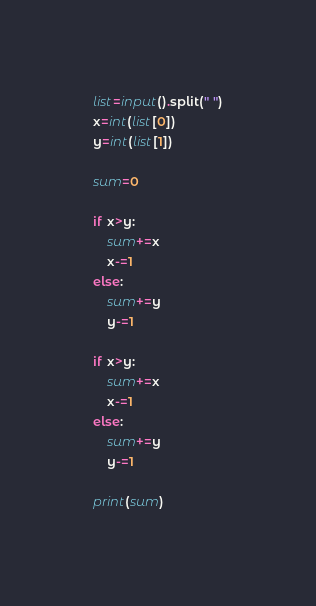Convert code to text. <code><loc_0><loc_0><loc_500><loc_500><_Python_>list=input().split(" ")
x=int(list[0])
y=int(list[1])

sum=0

if x>y:
    sum+=x
    x-=1
else:
    sum+=y
    y-=1

if x>y:
    sum+=x
    x-=1
else:
    sum+=y
    y-=1

print(sum)</code> 